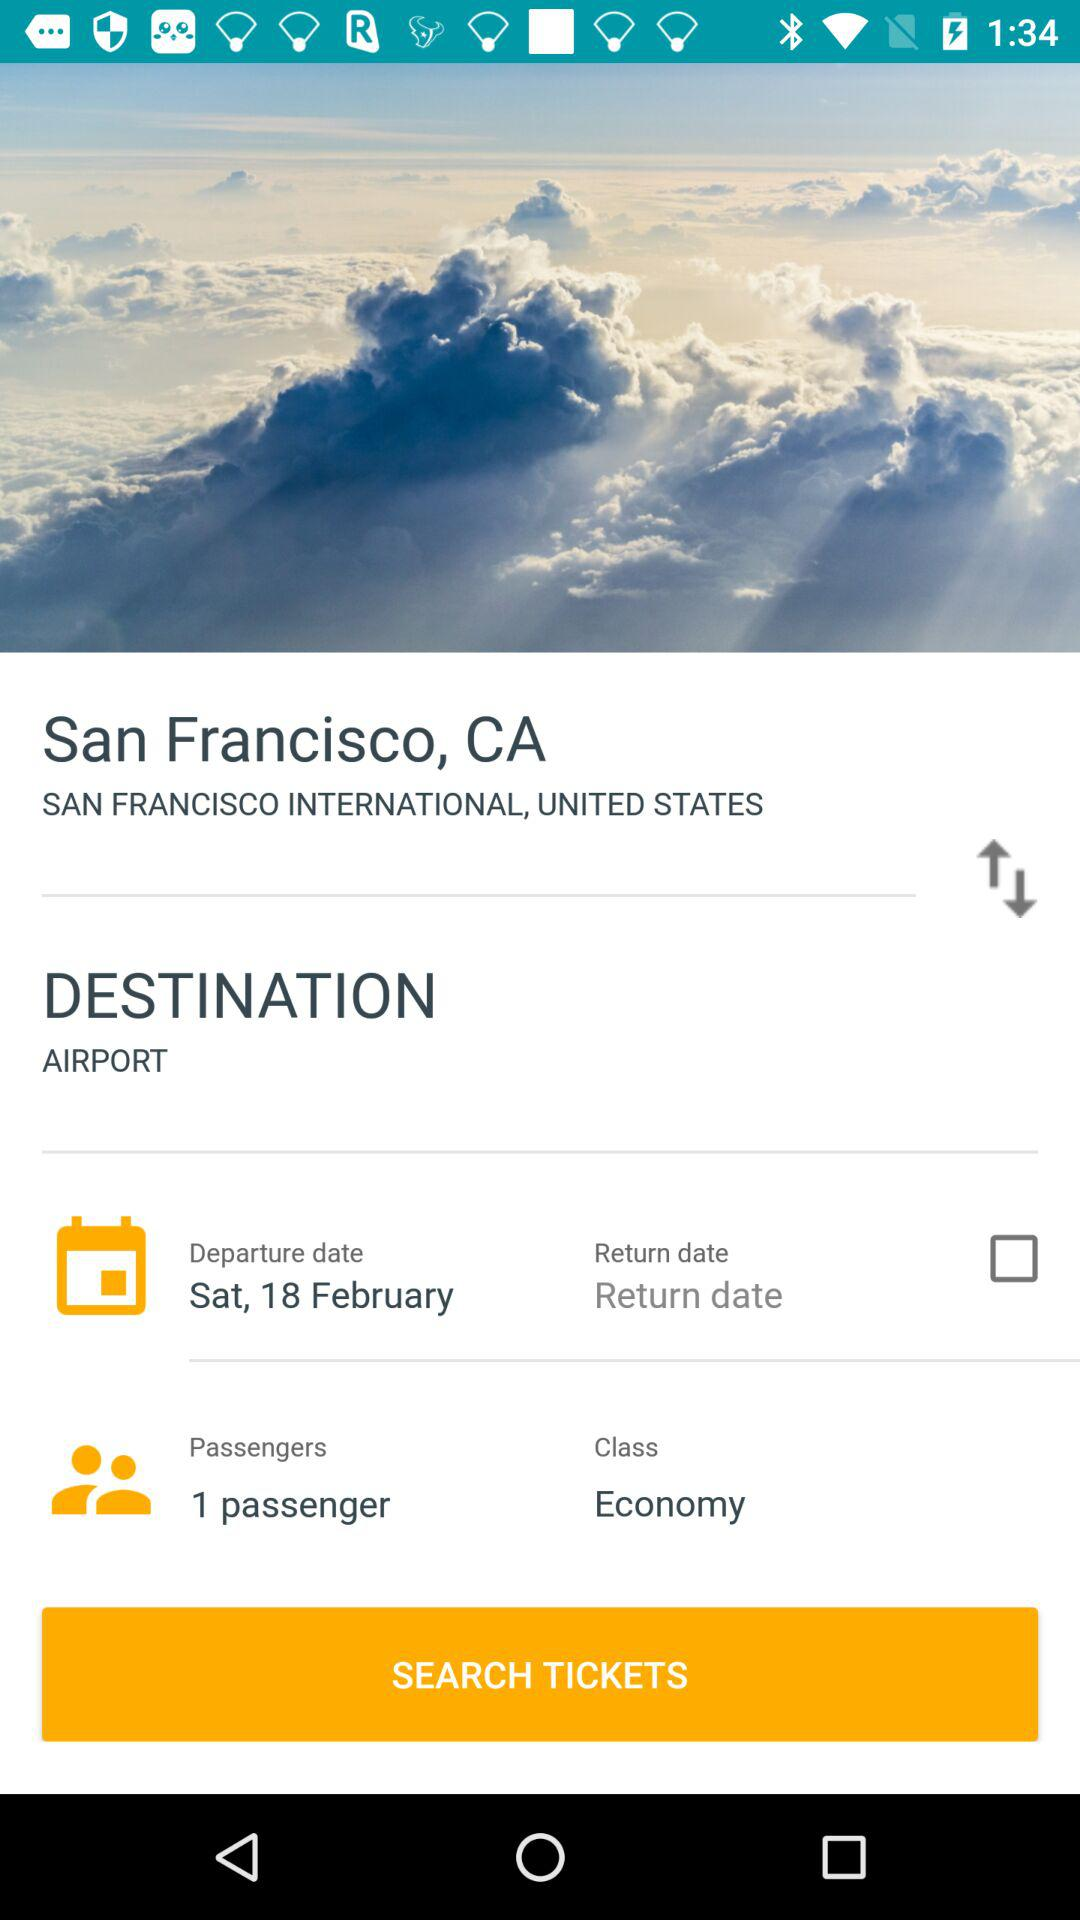What is the location? The location is San Francisco, CA. 